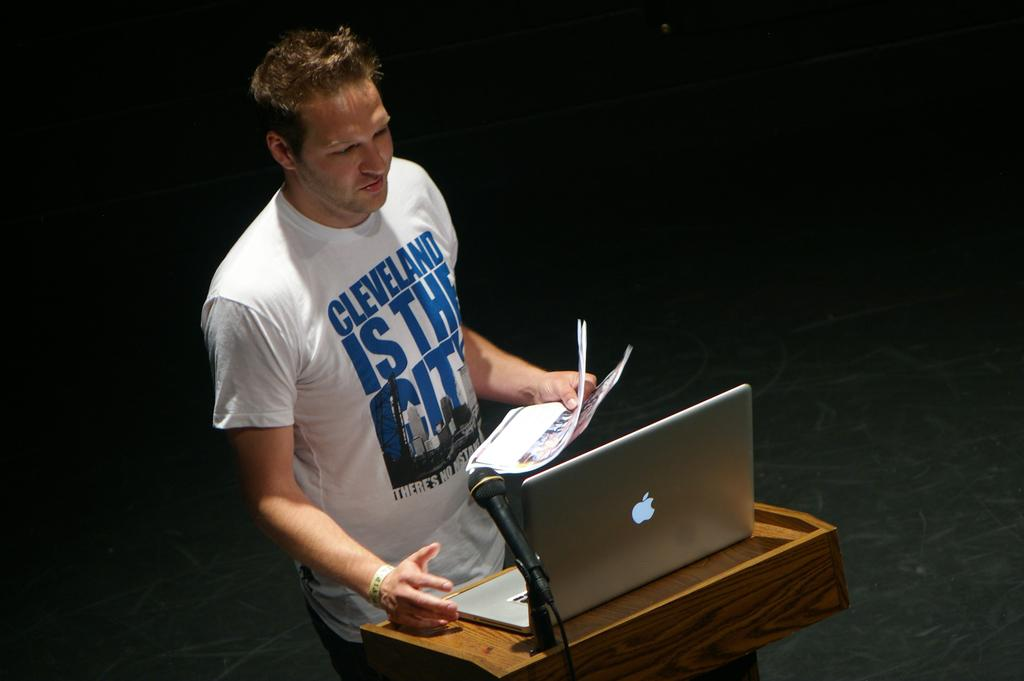<image>
Provide a brief description of the given image. man with cleveland is the city shirt at podium with a mac laptop on it 